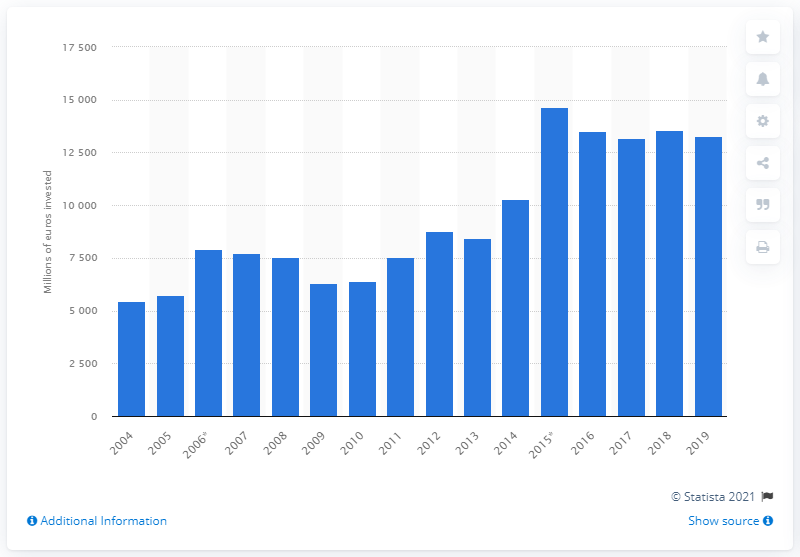List a handful of essential elements in this visual. In 2019, investment in rail transport infrastructure declined. The total investment in rail transport infrastructure in Great Britain from 2004 to 2019 was 132,984.4 million British pounds. The smallest amount of investment in rail transport infrastructure in 2004 was approximately 5450.9 million dollars. 